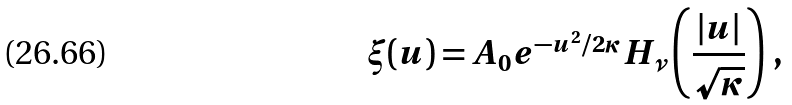Convert formula to latex. <formula><loc_0><loc_0><loc_500><loc_500>\xi ( u ) = A _ { 0 } e ^ { - u ^ { 2 } / 2 \kappa } H _ { \nu } \left ( \frac { | u | } { \sqrt { \kappa } } \right ) \, ,</formula> 